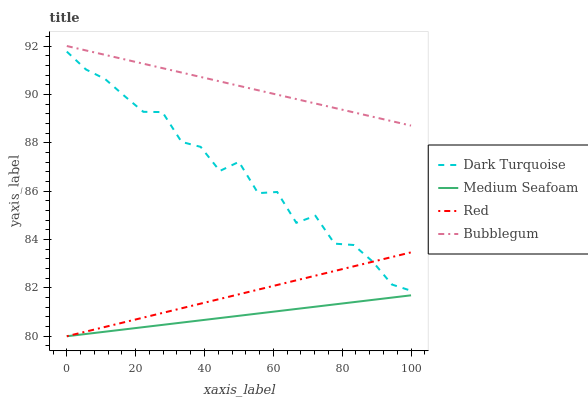Does Bubblegum have the minimum area under the curve?
Answer yes or no. No. Does Medium Seafoam have the maximum area under the curve?
Answer yes or no. No. Is Bubblegum the smoothest?
Answer yes or no. No. Is Bubblegum the roughest?
Answer yes or no. No. Does Bubblegum have the lowest value?
Answer yes or no. No. Does Medium Seafoam have the highest value?
Answer yes or no. No. Is Red less than Bubblegum?
Answer yes or no. Yes. Is Bubblegum greater than Medium Seafoam?
Answer yes or no. Yes. Does Red intersect Bubblegum?
Answer yes or no. No. 